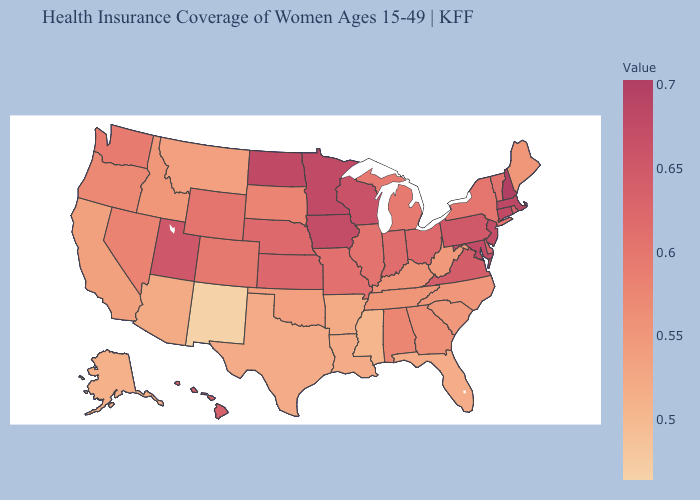Among the states that border Michigan , does Ohio have the lowest value?
Give a very brief answer. No. Among the states that border North Dakota , does Minnesota have the highest value?
Write a very short answer. Yes. Which states have the lowest value in the West?
Give a very brief answer. New Mexico. Does South Dakota have the lowest value in the MidWest?
Give a very brief answer. Yes. Which states hav the highest value in the West?
Answer briefly. Utah. 